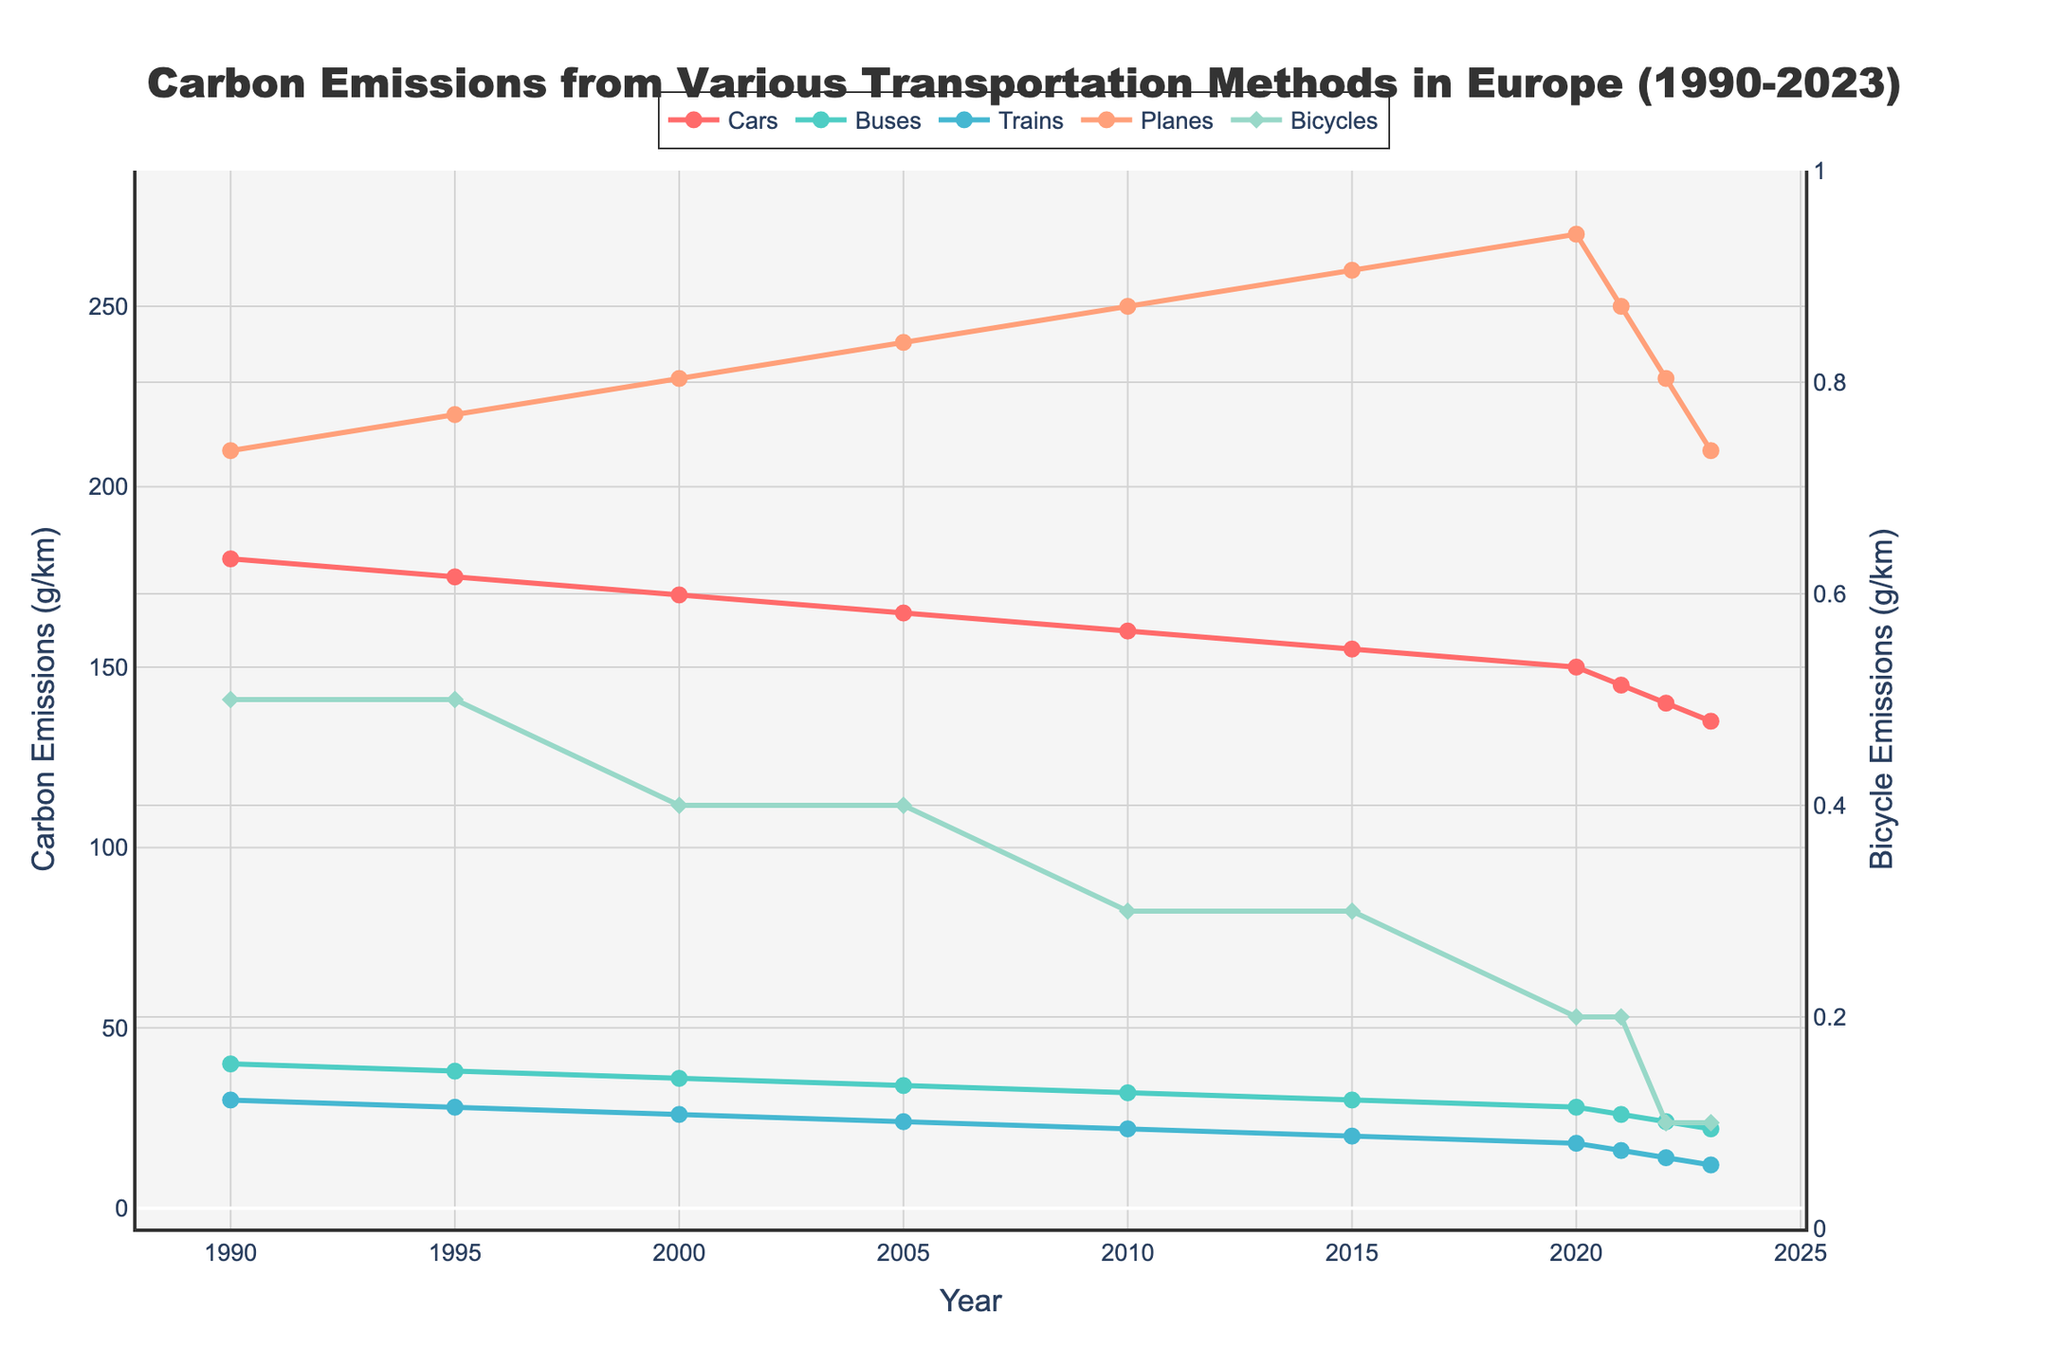What trend can be observed in the carbon emissions from cars from 1990 to 2023? The carbon emissions from cars show a consistent decreasing trend from 180 g/km in 1990 to 135 g/km in 2023.
Answer: Decreasing Which mode of transport had the highest carbon emissions in 2023? By looking at the 2023 data points, planes had the highest carbon emissions at 210 g/km.
Answer: Planes How do the carbon emissions from bicycles compare to those of buses in 2020? The carbon emissions from bicycles in 2020 was much lower at 0.2 g/km compared to 28 g/km for buses.
Answer: Much lower In which year did planes reach their peak carbon emissions, and what was the value? In the year 2020, planes reached their peak carbon emissions at 270 g/km.
Answer: 2020, 270 g/km What is the difference in carbon emissions between cars and trains in 2021? In 2021, the carbon emissions from cars were 145 g/km and for trains were 16 g/km, so the difference is 145 - 16 = 129 g/km.
Answer: 129 g/km What pattern can be seen in the carbon emissions from buses from 1990 to 2023? The carbon emissions from buses show a consistent decreasing trend from 40 g/km in 1990 to 22 g/km in 2023.
Answer: Decreasing Which two transportation methods had the closest carbon emission values in 2023, and what were their emissions? In 2023, buses had emissions of 22 g/km and trains had emissions of 12 g/km, making them the closest in value.
Answer: Buses (22 g/km), Trains (12 g/km) What is the average carbon emission from planes over the entire period from 1990 to 2023? The average can be calculated by summing up the carbon emissions from planes over all the years (210 + 220 + 230 + 240 + 250 + 260 + 270 + 250 + 230 + 210) and dividing by the number of years (10). The sum is 2370 g/km, so the average is 2370/10 = 237 g/km.
Answer: 237 g/km How did the carbon emissions from bicycles change from 1990 to 2023? The carbon emissions from bicycles showed a small decrease from 0.5 g/km in 1990 to 0.1 g/km in 2023 over the period.
Answer: Decreasing By how much did the carbon emissions from cars decrease from 1990 to 2023? The carbon emissions from cars decreased from 180 g/km in 1990 to 135 g/km in 2023, which is a reduction of 180 - 135 = 45 g/km.
Answer: 45 g/km 